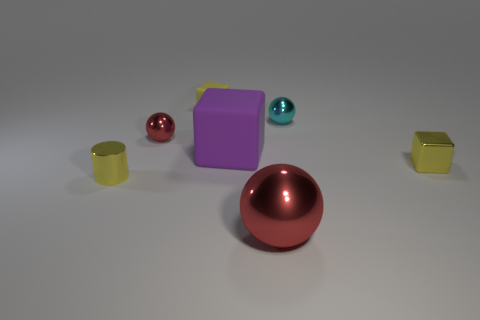Subtract all red balls. How many balls are left? 1 Subtract all tiny yellow rubber blocks. How many blocks are left? 2 Subtract 1 cubes. How many cubes are left? 2 Add 3 tiny things. How many objects exist? 10 Add 2 red rubber balls. How many red rubber balls exist? 2 Subtract 0 green cylinders. How many objects are left? 7 Subtract all spheres. How many objects are left? 4 Subtract all blue cylinders. Subtract all cyan blocks. How many cylinders are left? 1 Subtract all green cylinders. How many green spheres are left? 0 Subtract all small cylinders. Subtract all purple objects. How many objects are left? 5 